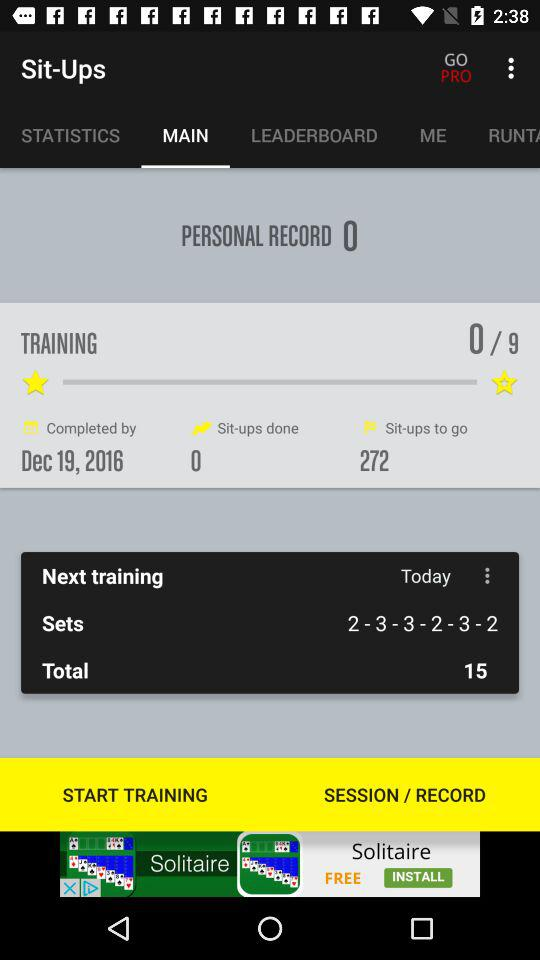How many total trainings? There are 9 total trainings. 